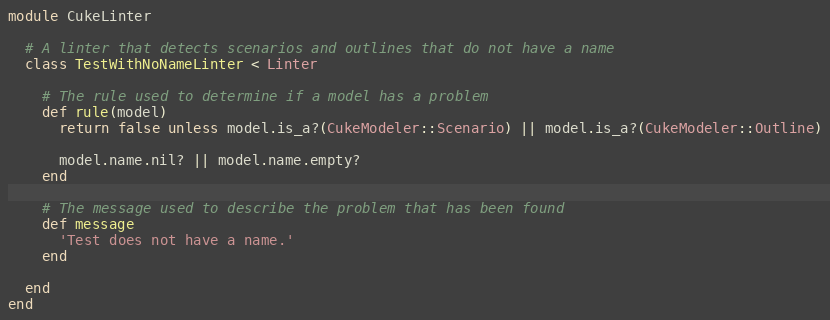<code> <loc_0><loc_0><loc_500><loc_500><_Ruby_>module CukeLinter

  # A linter that detects scenarios and outlines that do not have a name
  class TestWithNoNameLinter < Linter

    # The rule used to determine if a model has a problem
    def rule(model)
      return false unless model.is_a?(CukeModeler::Scenario) || model.is_a?(CukeModeler::Outline)

      model.name.nil? || model.name.empty?
    end

    # The message used to describe the problem that has been found
    def message
      'Test does not have a name.'
    end

  end
end
</code> 